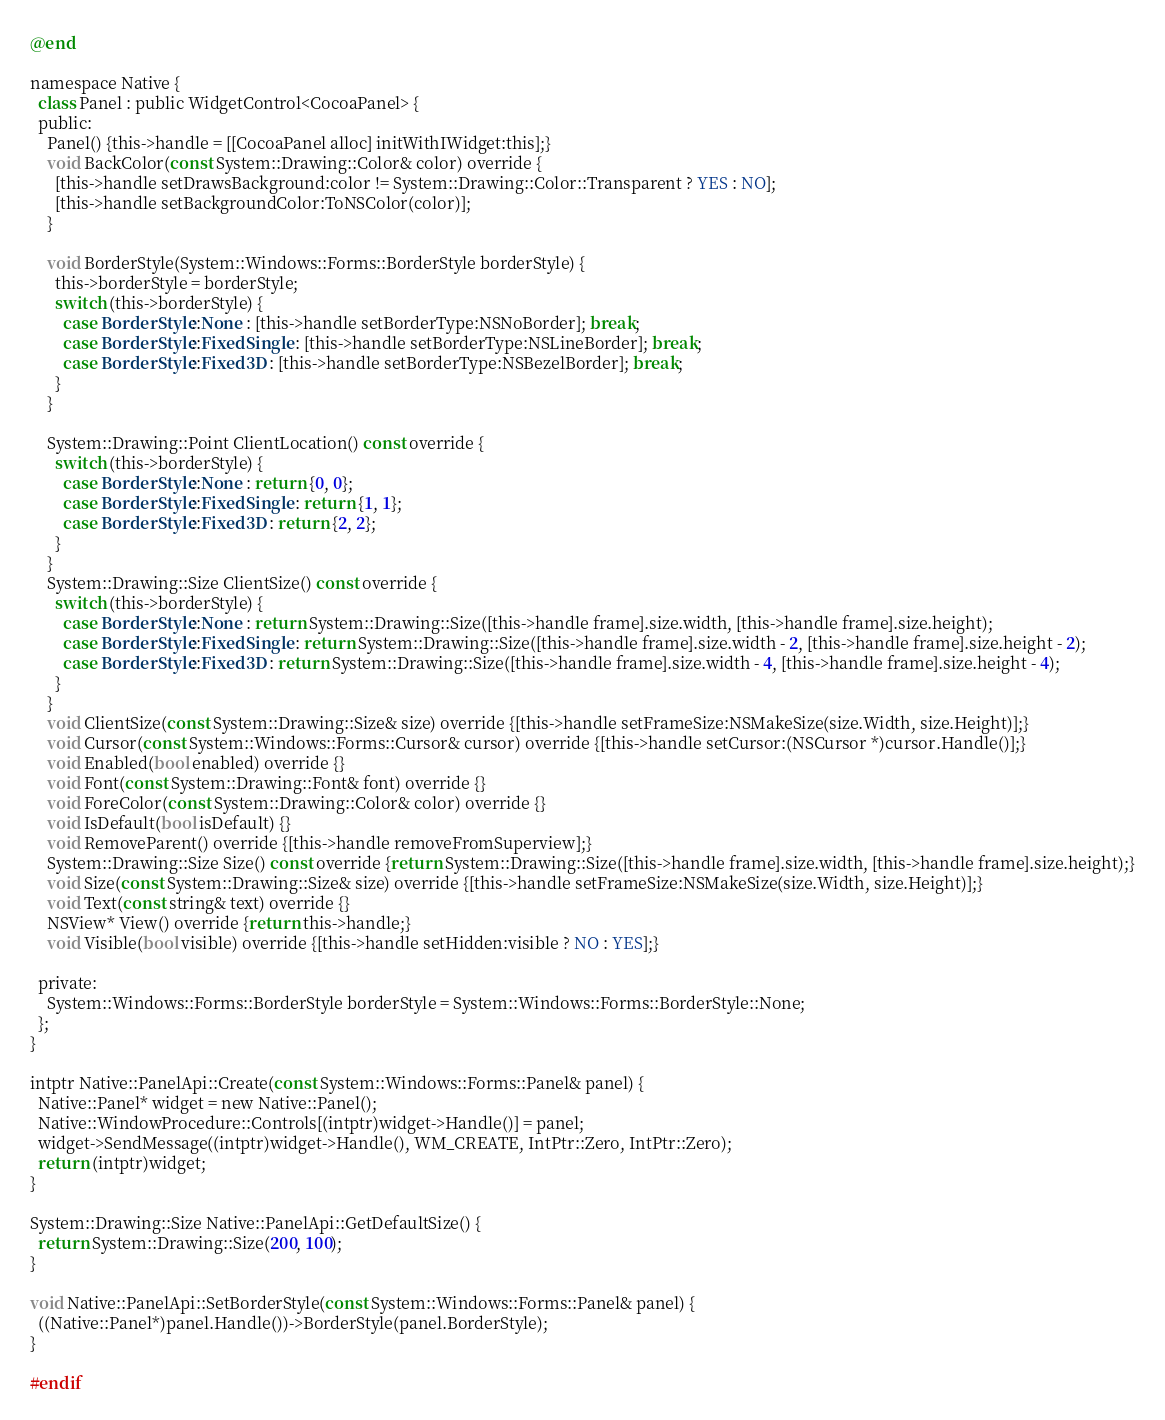<code> <loc_0><loc_0><loc_500><loc_500><_ObjectiveC_>@end

namespace Native {
  class Panel : public WidgetControl<CocoaPanel> {
  public:
    Panel() {this->handle = [[CocoaPanel alloc] initWithIWidget:this];}
    void BackColor(const System::Drawing::Color& color) override {
      [this->handle setDrawsBackground:color != System::Drawing::Color::Transparent ? YES : NO];
      [this->handle setBackgroundColor:ToNSColor(color)];
    }

    void BorderStyle(System::Windows::Forms::BorderStyle borderStyle) {
      this->borderStyle = borderStyle;
      switch (this->borderStyle) {
        case BorderStyle::None : [this->handle setBorderType:NSNoBorder]; break;
        case BorderStyle::FixedSingle : [this->handle setBorderType:NSLineBorder]; break;
        case BorderStyle::Fixed3D : [this->handle setBorderType:NSBezelBorder]; break;
      }
    }

    System::Drawing::Point ClientLocation() const override {
      switch (this->borderStyle) {
        case BorderStyle::None : return {0, 0};
        case BorderStyle::FixedSingle : return {1, 1};
        case BorderStyle::Fixed3D : return {2, 2};
      }
    }
    System::Drawing::Size ClientSize() const override {
      switch (this->borderStyle) {
        case BorderStyle::None : return System::Drawing::Size([this->handle frame].size.width, [this->handle frame].size.height);
        case BorderStyle::FixedSingle : return System::Drawing::Size([this->handle frame].size.width - 2, [this->handle frame].size.height - 2);
        case BorderStyle::Fixed3D : return System::Drawing::Size([this->handle frame].size.width - 4, [this->handle frame].size.height - 4);
      }
    }
    void ClientSize(const System::Drawing::Size& size) override {[this->handle setFrameSize:NSMakeSize(size.Width, size.Height)];}
    void Cursor(const System::Windows::Forms::Cursor& cursor) override {[this->handle setCursor:(NSCursor *)cursor.Handle()];}
    void Enabled(bool enabled) override {}
    void Font(const System::Drawing::Font& font) override {}
    void ForeColor(const System::Drawing::Color& color) override {}
    void IsDefault(bool isDefault) {}
    void RemoveParent() override {[this->handle removeFromSuperview];}
    System::Drawing::Size Size() const override {return System::Drawing::Size([this->handle frame].size.width, [this->handle frame].size.height);}
    void Size(const System::Drawing::Size& size) override {[this->handle setFrameSize:NSMakeSize(size.Width, size.Height)];}
    void Text(const string& text) override {}
    NSView* View() override {return this->handle;}
    void Visible(bool visible) override {[this->handle setHidden:visible ? NO : YES];}

  private:
    System::Windows::Forms::BorderStyle borderStyle = System::Windows::Forms::BorderStyle::None;
  };
}

intptr Native::PanelApi::Create(const System::Windows::Forms::Panel& panel) {
  Native::Panel* widget = new Native::Panel();
  Native::WindowProcedure::Controls[(intptr)widget->Handle()] = panel;
  widget->SendMessage((intptr)widget->Handle(), WM_CREATE, IntPtr::Zero, IntPtr::Zero);
  return (intptr)widget;
}

System::Drawing::Size Native::PanelApi::GetDefaultSize() {
  return System::Drawing::Size(200, 100);
}

void Native::PanelApi::SetBorderStyle(const System::Windows::Forms::Panel& panel) {
  ((Native::Panel*)panel.Handle())->BorderStyle(panel.BorderStyle);
}

#endif
</code> 